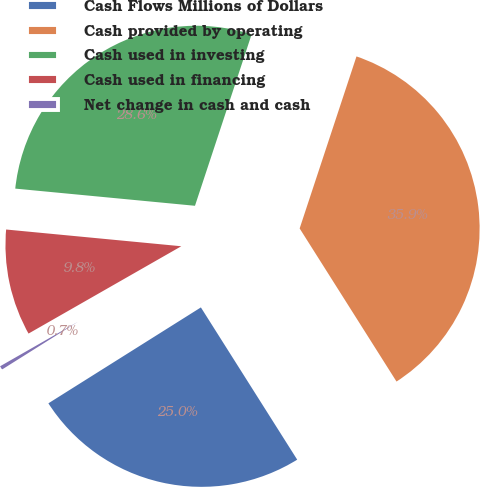Convert chart to OTSL. <chart><loc_0><loc_0><loc_500><loc_500><pie_chart><fcel>Cash Flows Millions of Dollars<fcel>Cash provided by operating<fcel>Cash used in investing<fcel>Cash used in financing<fcel>Net change in cash and cash<nl><fcel>25.04%<fcel>35.94%<fcel>28.56%<fcel>9.78%<fcel>0.67%<nl></chart> 